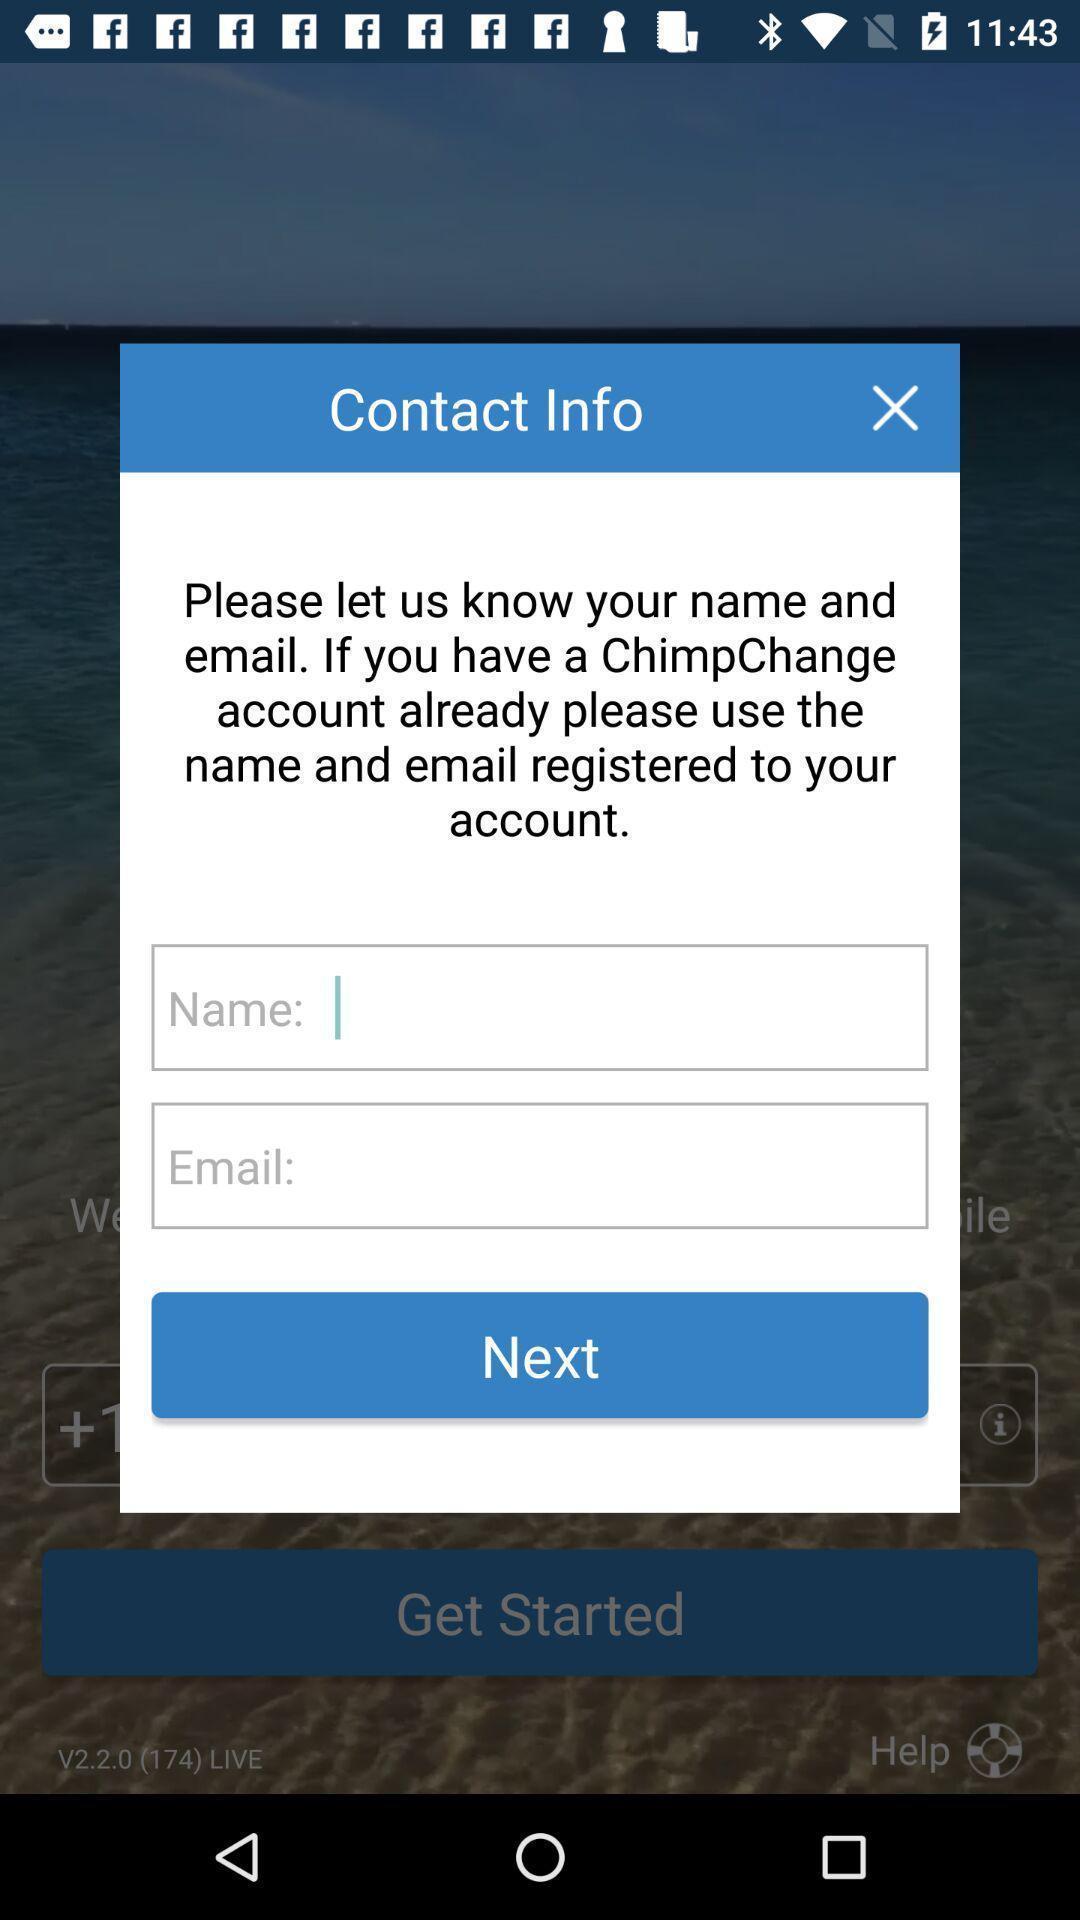What details can you identify in this image? Push up displaying to enter details. 